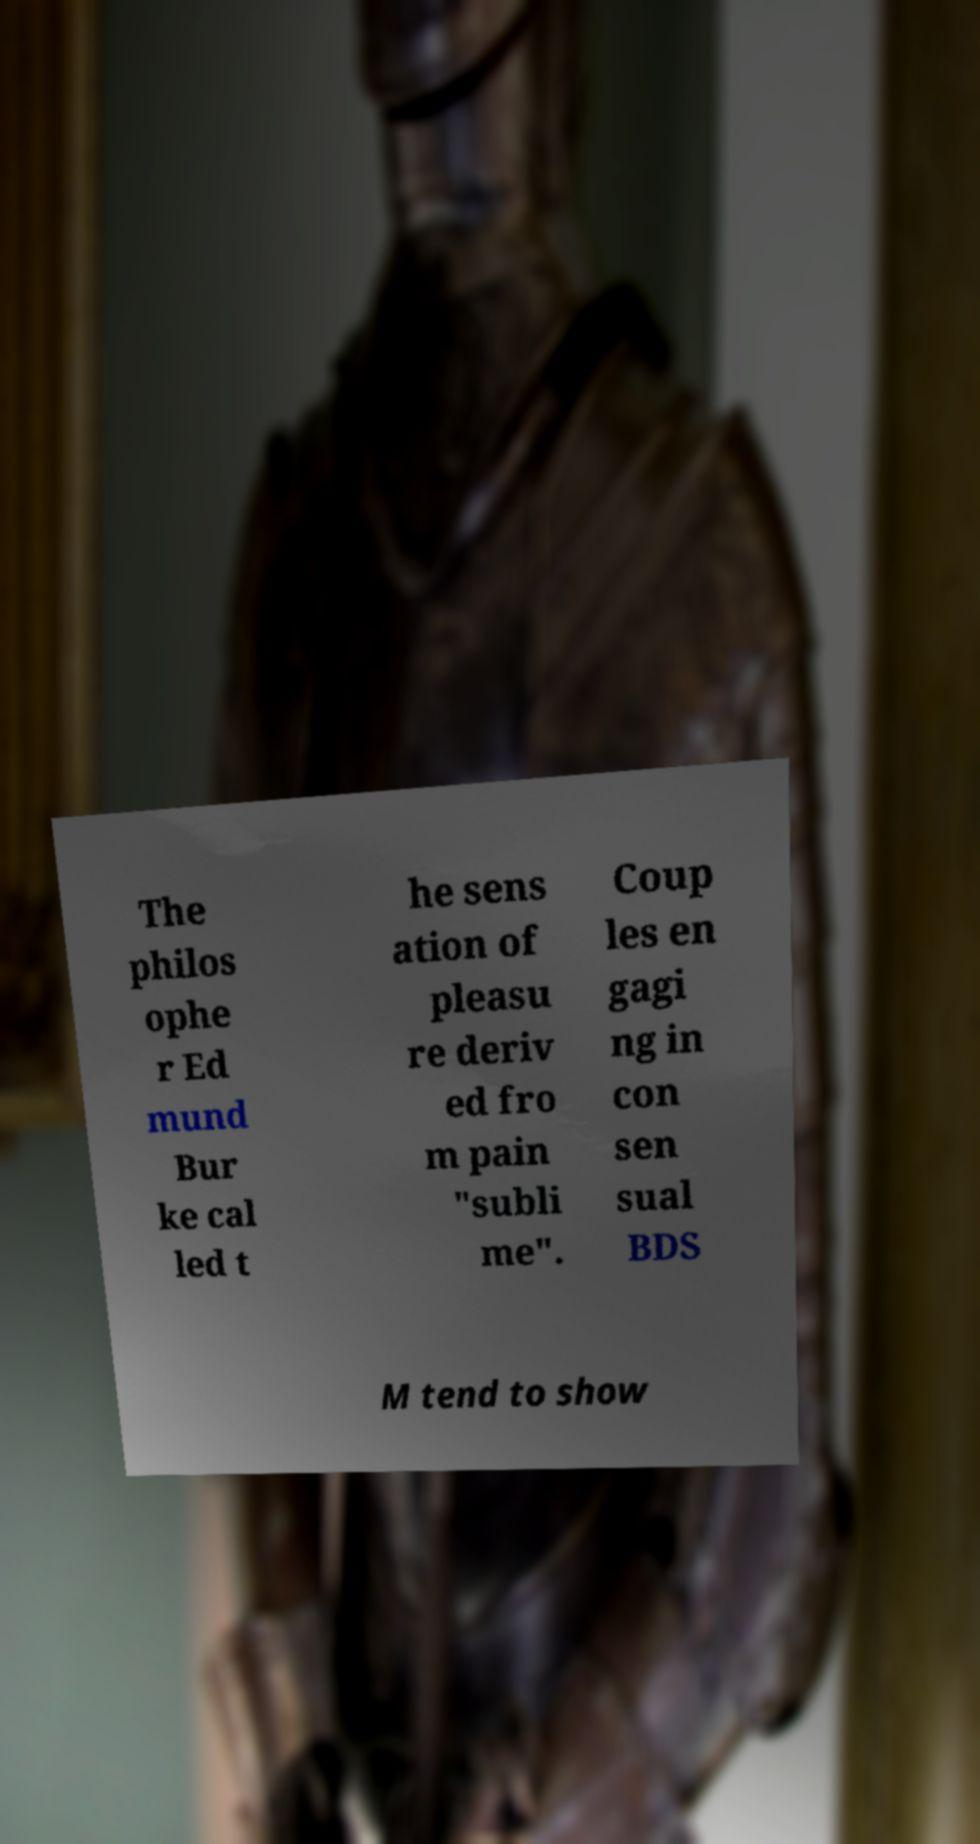There's text embedded in this image that I need extracted. Can you transcribe it verbatim? The philos ophe r Ed mund Bur ke cal led t he sens ation of pleasu re deriv ed fro m pain "subli me". Coup les en gagi ng in con sen sual BDS M tend to show 